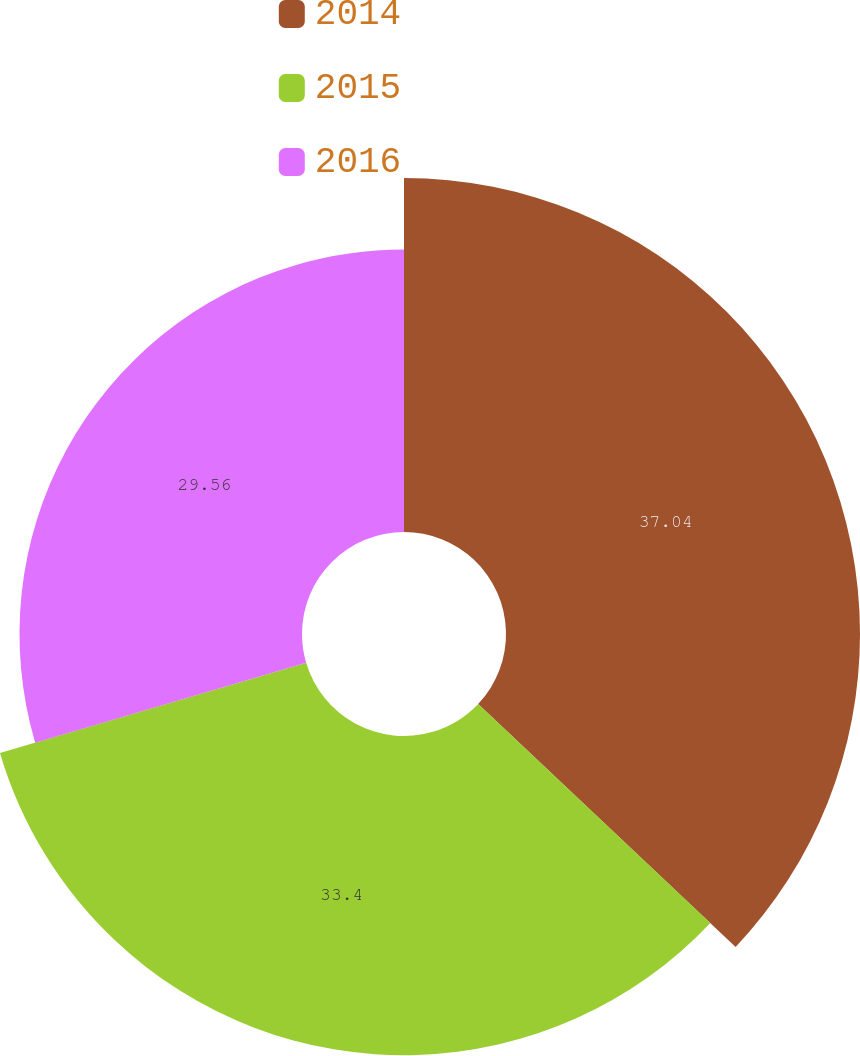Convert chart to OTSL. <chart><loc_0><loc_0><loc_500><loc_500><pie_chart><fcel>2014<fcel>2015<fcel>2016<nl><fcel>37.04%<fcel>33.4%<fcel>29.56%<nl></chart> 